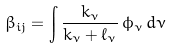Convert formula to latex. <formula><loc_0><loc_0><loc_500><loc_500>\beta _ { i j } = \int \frac { k _ { \nu } } { k _ { \nu } + \ell _ { \nu } } \, \phi _ { \nu } \, d \nu</formula> 